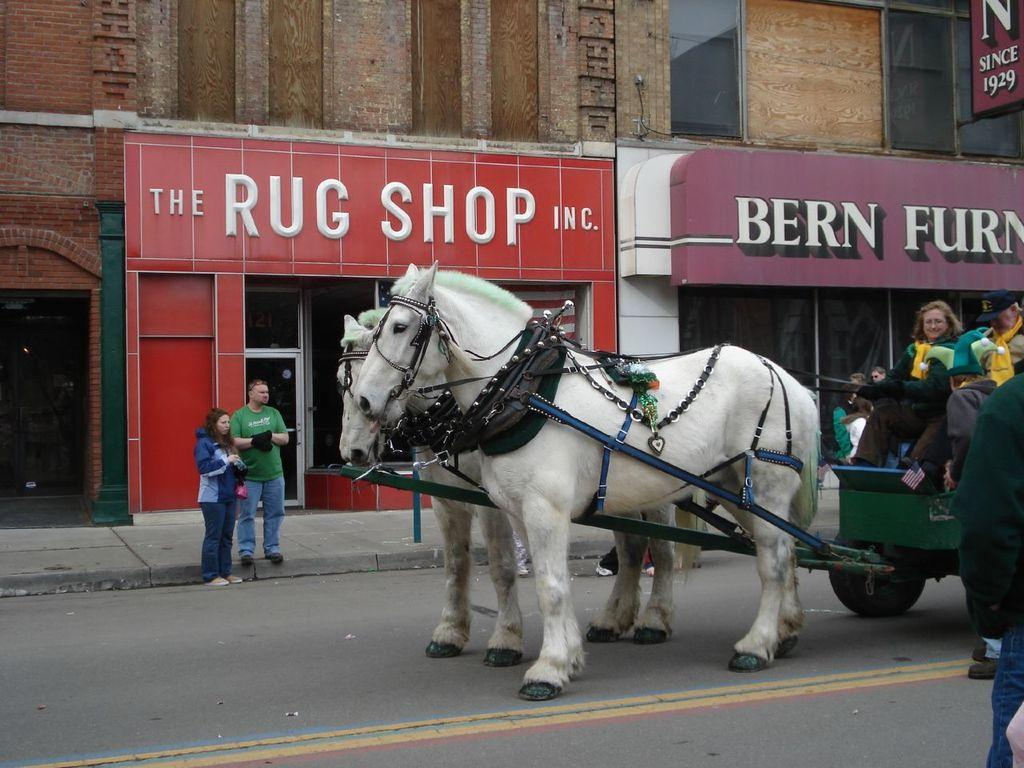What are the people doing on the road in the image? There are people riding horse carts on the road in the image. What else can be seen near the road? There are people beside the road in the image. What is visible in the background of the image? There are buildings and hoardings in the background of the image. What type of pets are being used to reason with the horse carts in the image? There are no pets present in the image, and the horse carts are not being used with any reasoning assistance. 